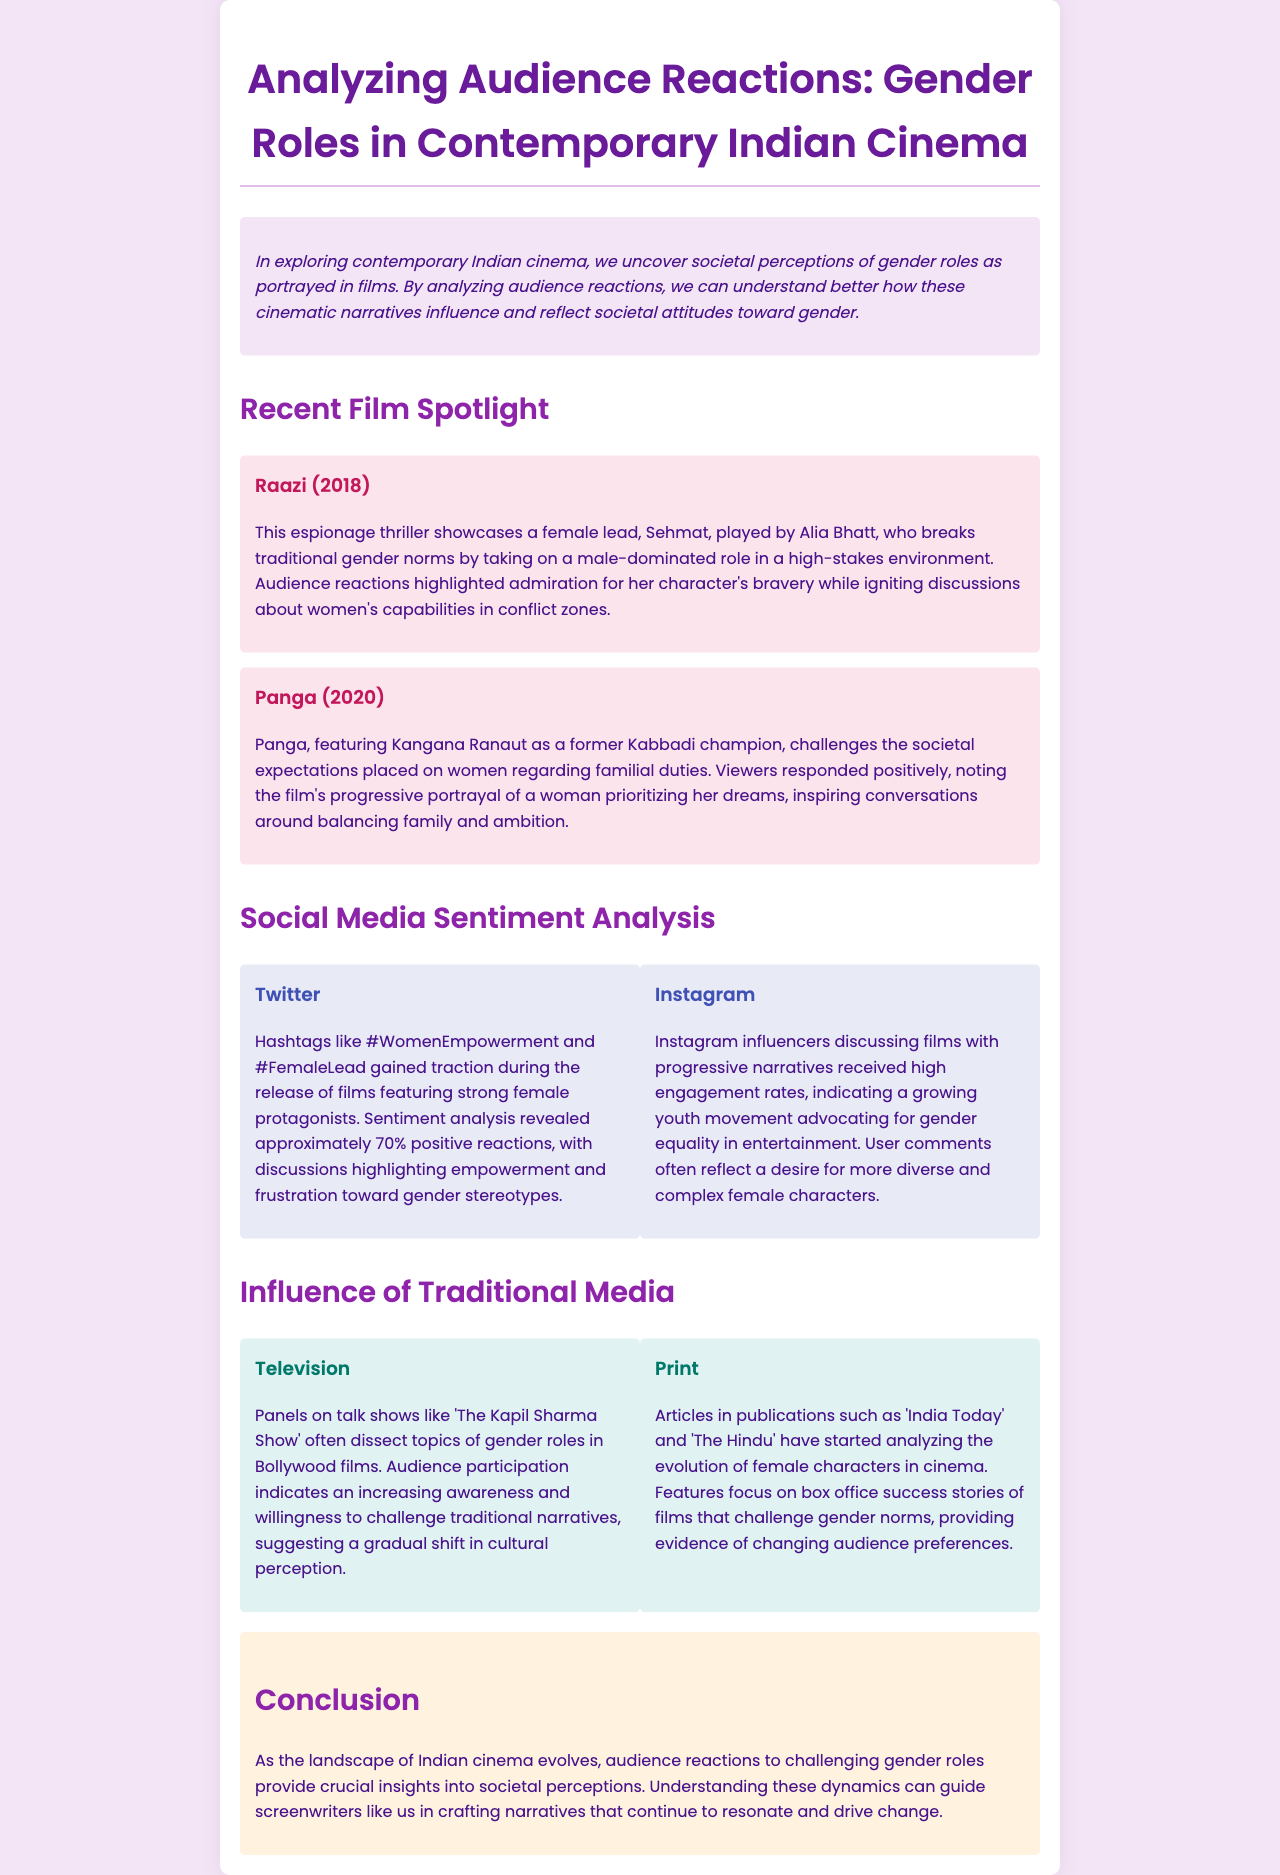what is the title of the newsletter? The title of the newsletter is found in the heading at the top of the document.
Answer: Analyzing Audience Reactions: Gender Roles in Contemporary Indian Cinema who played the female lead in Raazi? The document specifies the actress who portrayed the lead character in Raazi.
Answer: Alia Bhatt what percentage of positive reactions were observed on Twitter? The document mentions a specific figure regarding the sentiment analysis for Twitter.
Answer: 70% which film features Kangana Ranaut? The document identifies the film in which this actress stars and discusses gender roles.
Answer: Panga what is a primary theme discussed in the conclusion? The conclusion recaps a significant focus of the newsletter, which is hinted at throughout.
Answer: societal perceptions how did audience reactions to Panga influence discussions? The document describes the impact of audience reactions on broader conversations regarding gender roles.
Answer: balancing family and ambition what type of media is highlighted for discussing gender roles outside of films? The newsletter describes the role of various traditional media platforms in analyzing gender roles.
Answer: Television which social media platform shows high engagement rates for progressive narratives? The document presents specific platforms where discussions about gender roles occur.
Answer: Instagram 